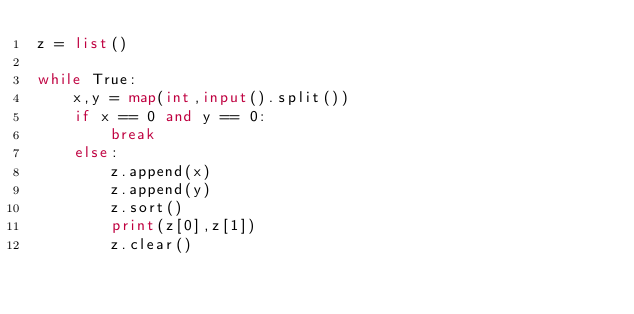<code> <loc_0><loc_0><loc_500><loc_500><_Python_>z = list()

while True:
    x,y = map(int,input().split())
    if x == 0 and y == 0:
        break
    else:
        z.append(x)
        z.append(y)
        z.sort()
        print(z[0],z[1])
        z.clear()
</code> 